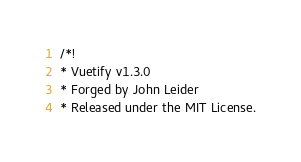<code> <loc_0><loc_0><loc_500><loc_500><_CSS_>/*!
* Vuetify v1.3.0
* Forged by John Leider
* Released under the MIT License.</code> 